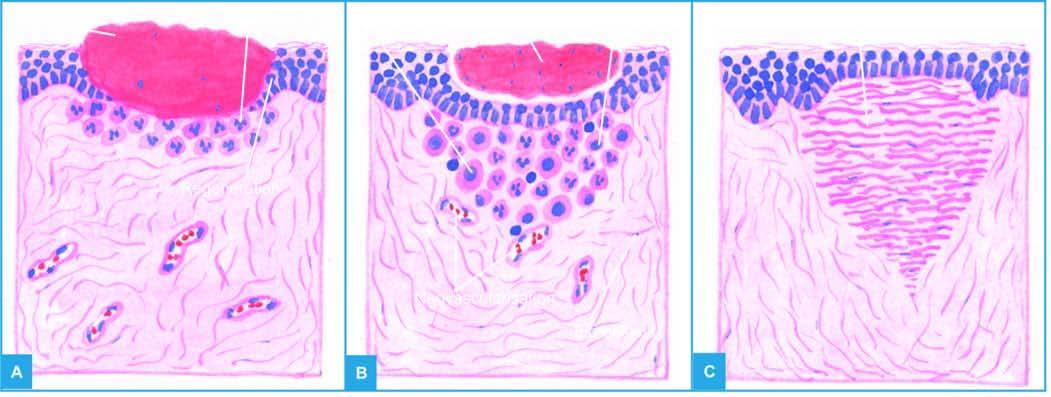what is filled with blood clot?
Answer the question using a single word or phrase. The open wound 